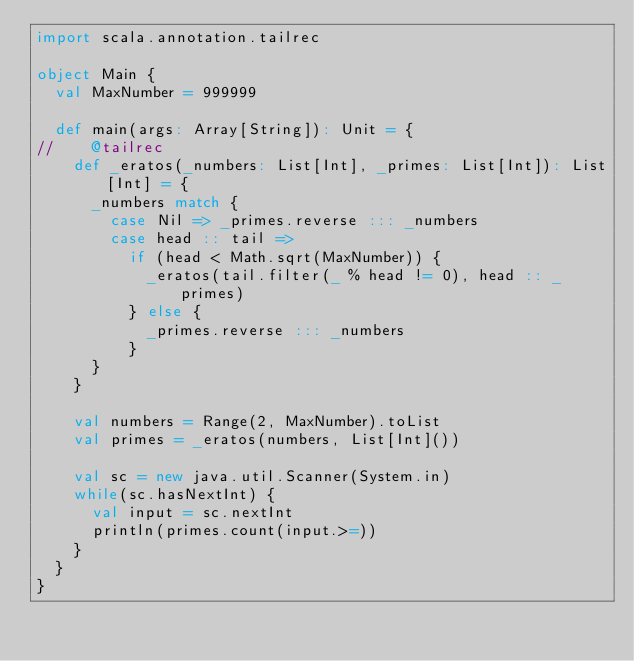Convert code to text. <code><loc_0><loc_0><loc_500><loc_500><_Scala_>import scala.annotation.tailrec

object Main {
  val MaxNumber = 999999

  def main(args: Array[String]): Unit = {
//    @tailrec
    def _eratos(_numbers: List[Int], _primes: List[Int]): List[Int] = {
      _numbers match {
        case Nil => _primes.reverse ::: _numbers
        case head :: tail =>
          if (head < Math.sqrt(MaxNumber)) {
            _eratos(tail.filter(_ % head != 0), head :: _primes)
          } else {
            _primes.reverse ::: _numbers
          }
      }
    }

    val numbers = Range(2, MaxNumber).toList
    val primes = _eratos(numbers, List[Int]())

    val sc = new java.util.Scanner(System.in)
    while(sc.hasNextInt) {
      val input = sc.nextInt
      println(primes.count(input.>=))
    }
  }
}</code> 